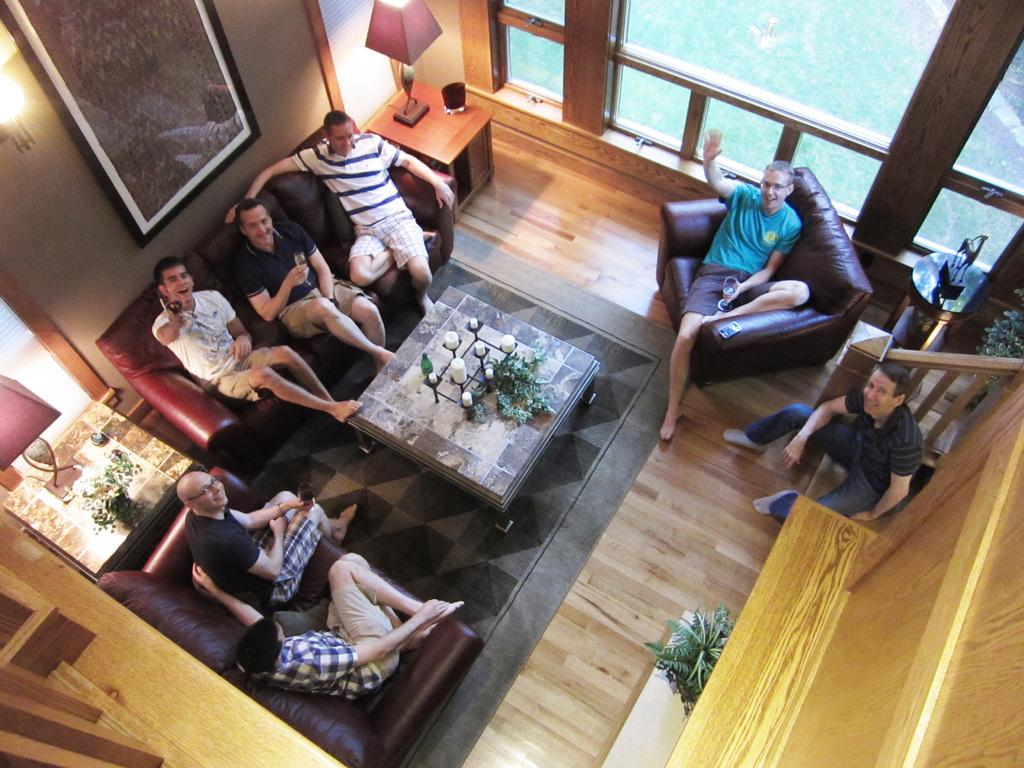How many people are sitting on the couch in the image? There are seven people sitting on the couch in the image. What other furniture can be seen in the image? There is a table in the image. What is on the table? There is a lamp on the table. What type of marble is visible on the floor in the image? There is no marble visible on the floor in the image. Can you see a goat in the image? No, there is no goat present in the image. 